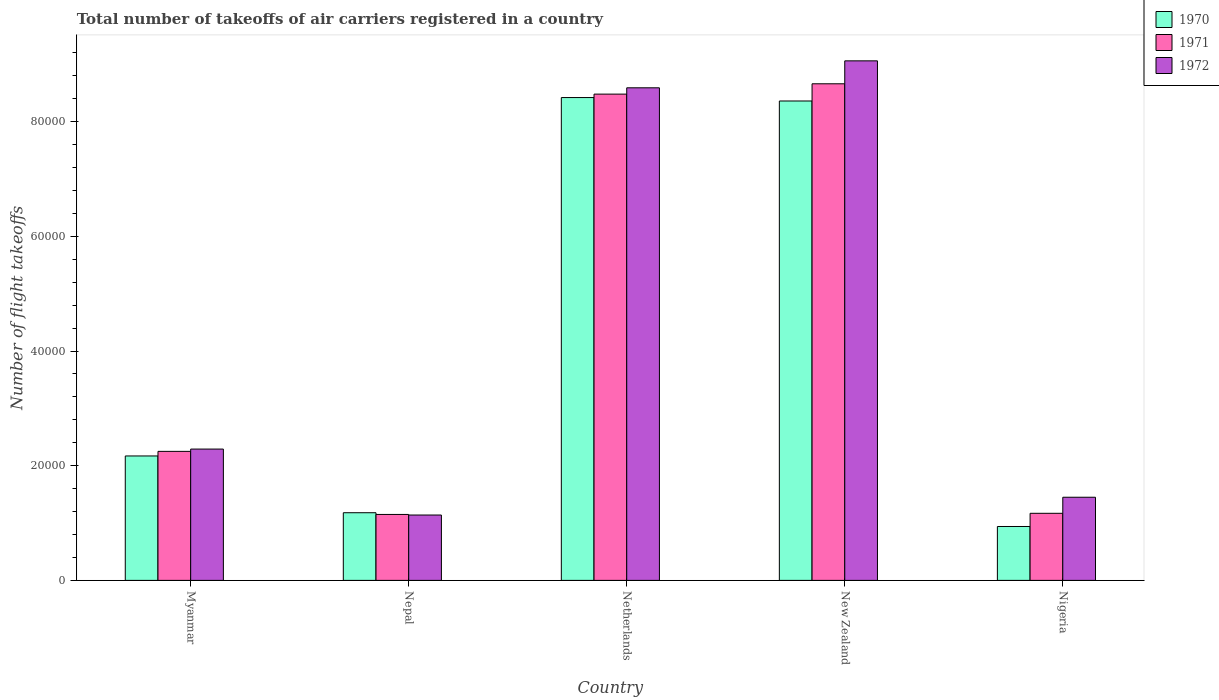How many different coloured bars are there?
Offer a very short reply. 3. How many groups of bars are there?
Offer a very short reply. 5. Are the number of bars per tick equal to the number of legend labels?
Offer a very short reply. Yes. How many bars are there on the 4th tick from the left?
Provide a short and direct response. 3. How many bars are there on the 4th tick from the right?
Make the answer very short. 3. What is the label of the 1st group of bars from the left?
Your answer should be compact. Myanmar. What is the total number of flight takeoffs in 1972 in Nepal?
Your answer should be very brief. 1.14e+04. Across all countries, what is the maximum total number of flight takeoffs in 1972?
Your answer should be very brief. 9.06e+04. Across all countries, what is the minimum total number of flight takeoffs in 1970?
Offer a very short reply. 9400. In which country was the total number of flight takeoffs in 1972 minimum?
Offer a very short reply. Nepal. What is the total total number of flight takeoffs in 1971 in the graph?
Make the answer very short. 2.17e+05. What is the difference between the total number of flight takeoffs in 1972 in Nepal and that in Nigeria?
Provide a succinct answer. -3100. What is the difference between the total number of flight takeoffs in 1972 in Netherlands and the total number of flight takeoffs in 1971 in Nigeria?
Offer a terse response. 7.42e+04. What is the average total number of flight takeoffs in 1971 per country?
Your response must be concise. 4.34e+04. What is the ratio of the total number of flight takeoffs in 1970 in Myanmar to that in Netherlands?
Offer a very short reply. 0.26. What is the difference between the highest and the second highest total number of flight takeoffs in 1971?
Make the answer very short. 1800. What is the difference between the highest and the lowest total number of flight takeoffs in 1972?
Give a very brief answer. 7.92e+04. Is the sum of the total number of flight takeoffs in 1971 in Nepal and Netherlands greater than the maximum total number of flight takeoffs in 1972 across all countries?
Provide a succinct answer. Yes. What does the 3rd bar from the left in Netherlands represents?
Provide a short and direct response. 1972. What does the 2nd bar from the right in Nigeria represents?
Provide a succinct answer. 1971. Is it the case that in every country, the sum of the total number of flight takeoffs in 1972 and total number of flight takeoffs in 1971 is greater than the total number of flight takeoffs in 1970?
Your response must be concise. Yes. Are all the bars in the graph horizontal?
Ensure brevity in your answer.  No. Does the graph contain any zero values?
Make the answer very short. No. Where does the legend appear in the graph?
Make the answer very short. Top right. How many legend labels are there?
Your answer should be very brief. 3. What is the title of the graph?
Offer a terse response. Total number of takeoffs of air carriers registered in a country. Does "1979" appear as one of the legend labels in the graph?
Your answer should be very brief. No. What is the label or title of the X-axis?
Provide a short and direct response. Country. What is the label or title of the Y-axis?
Your answer should be very brief. Number of flight takeoffs. What is the Number of flight takeoffs of 1970 in Myanmar?
Make the answer very short. 2.17e+04. What is the Number of flight takeoffs in 1971 in Myanmar?
Offer a terse response. 2.25e+04. What is the Number of flight takeoffs of 1972 in Myanmar?
Provide a short and direct response. 2.29e+04. What is the Number of flight takeoffs in 1970 in Nepal?
Your answer should be compact. 1.18e+04. What is the Number of flight takeoffs in 1971 in Nepal?
Provide a succinct answer. 1.15e+04. What is the Number of flight takeoffs of 1972 in Nepal?
Your answer should be very brief. 1.14e+04. What is the Number of flight takeoffs in 1970 in Netherlands?
Give a very brief answer. 8.42e+04. What is the Number of flight takeoffs of 1971 in Netherlands?
Ensure brevity in your answer.  8.48e+04. What is the Number of flight takeoffs in 1972 in Netherlands?
Provide a short and direct response. 8.59e+04. What is the Number of flight takeoffs of 1970 in New Zealand?
Provide a short and direct response. 8.36e+04. What is the Number of flight takeoffs in 1971 in New Zealand?
Provide a succinct answer. 8.66e+04. What is the Number of flight takeoffs of 1972 in New Zealand?
Provide a succinct answer. 9.06e+04. What is the Number of flight takeoffs in 1970 in Nigeria?
Ensure brevity in your answer.  9400. What is the Number of flight takeoffs in 1971 in Nigeria?
Give a very brief answer. 1.17e+04. What is the Number of flight takeoffs in 1972 in Nigeria?
Provide a succinct answer. 1.45e+04. Across all countries, what is the maximum Number of flight takeoffs in 1970?
Ensure brevity in your answer.  8.42e+04. Across all countries, what is the maximum Number of flight takeoffs in 1971?
Your response must be concise. 8.66e+04. Across all countries, what is the maximum Number of flight takeoffs of 1972?
Offer a terse response. 9.06e+04. Across all countries, what is the minimum Number of flight takeoffs in 1970?
Your response must be concise. 9400. Across all countries, what is the minimum Number of flight takeoffs in 1971?
Give a very brief answer. 1.15e+04. Across all countries, what is the minimum Number of flight takeoffs in 1972?
Your answer should be very brief. 1.14e+04. What is the total Number of flight takeoffs in 1970 in the graph?
Provide a short and direct response. 2.11e+05. What is the total Number of flight takeoffs in 1971 in the graph?
Provide a succinct answer. 2.17e+05. What is the total Number of flight takeoffs of 1972 in the graph?
Give a very brief answer. 2.25e+05. What is the difference between the Number of flight takeoffs of 1970 in Myanmar and that in Nepal?
Your answer should be very brief. 9900. What is the difference between the Number of flight takeoffs of 1971 in Myanmar and that in Nepal?
Your answer should be compact. 1.10e+04. What is the difference between the Number of flight takeoffs in 1972 in Myanmar and that in Nepal?
Offer a very short reply. 1.15e+04. What is the difference between the Number of flight takeoffs of 1970 in Myanmar and that in Netherlands?
Provide a short and direct response. -6.25e+04. What is the difference between the Number of flight takeoffs in 1971 in Myanmar and that in Netherlands?
Your answer should be very brief. -6.23e+04. What is the difference between the Number of flight takeoffs of 1972 in Myanmar and that in Netherlands?
Give a very brief answer. -6.30e+04. What is the difference between the Number of flight takeoffs in 1970 in Myanmar and that in New Zealand?
Keep it short and to the point. -6.19e+04. What is the difference between the Number of flight takeoffs in 1971 in Myanmar and that in New Zealand?
Provide a short and direct response. -6.41e+04. What is the difference between the Number of flight takeoffs in 1972 in Myanmar and that in New Zealand?
Your response must be concise. -6.77e+04. What is the difference between the Number of flight takeoffs in 1970 in Myanmar and that in Nigeria?
Keep it short and to the point. 1.23e+04. What is the difference between the Number of flight takeoffs in 1971 in Myanmar and that in Nigeria?
Give a very brief answer. 1.08e+04. What is the difference between the Number of flight takeoffs in 1972 in Myanmar and that in Nigeria?
Give a very brief answer. 8400. What is the difference between the Number of flight takeoffs of 1970 in Nepal and that in Netherlands?
Offer a terse response. -7.24e+04. What is the difference between the Number of flight takeoffs of 1971 in Nepal and that in Netherlands?
Keep it short and to the point. -7.33e+04. What is the difference between the Number of flight takeoffs of 1972 in Nepal and that in Netherlands?
Your response must be concise. -7.45e+04. What is the difference between the Number of flight takeoffs in 1970 in Nepal and that in New Zealand?
Offer a terse response. -7.18e+04. What is the difference between the Number of flight takeoffs of 1971 in Nepal and that in New Zealand?
Your answer should be very brief. -7.51e+04. What is the difference between the Number of flight takeoffs in 1972 in Nepal and that in New Zealand?
Make the answer very short. -7.92e+04. What is the difference between the Number of flight takeoffs in 1970 in Nepal and that in Nigeria?
Your answer should be very brief. 2400. What is the difference between the Number of flight takeoffs of 1971 in Nepal and that in Nigeria?
Give a very brief answer. -200. What is the difference between the Number of flight takeoffs of 1972 in Nepal and that in Nigeria?
Offer a very short reply. -3100. What is the difference between the Number of flight takeoffs of 1970 in Netherlands and that in New Zealand?
Ensure brevity in your answer.  600. What is the difference between the Number of flight takeoffs in 1971 in Netherlands and that in New Zealand?
Your answer should be very brief. -1800. What is the difference between the Number of flight takeoffs of 1972 in Netherlands and that in New Zealand?
Offer a very short reply. -4700. What is the difference between the Number of flight takeoffs of 1970 in Netherlands and that in Nigeria?
Make the answer very short. 7.48e+04. What is the difference between the Number of flight takeoffs of 1971 in Netherlands and that in Nigeria?
Provide a short and direct response. 7.31e+04. What is the difference between the Number of flight takeoffs in 1972 in Netherlands and that in Nigeria?
Your answer should be very brief. 7.14e+04. What is the difference between the Number of flight takeoffs in 1970 in New Zealand and that in Nigeria?
Give a very brief answer. 7.42e+04. What is the difference between the Number of flight takeoffs in 1971 in New Zealand and that in Nigeria?
Your answer should be compact. 7.49e+04. What is the difference between the Number of flight takeoffs of 1972 in New Zealand and that in Nigeria?
Give a very brief answer. 7.61e+04. What is the difference between the Number of flight takeoffs in 1970 in Myanmar and the Number of flight takeoffs in 1971 in Nepal?
Offer a terse response. 1.02e+04. What is the difference between the Number of flight takeoffs of 1970 in Myanmar and the Number of flight takeoffs of 1972 in Nepal?
Keep it short and to the point. 1.03e+04. What is the difference between the Number of flight takeoffs of 1971 in Myanmar and the Number of flight takeoffs of 1972 in Nepal?
Keep it short and to the point. 1.11e+04. What is the difference between the Number of flight takeoffs in 1970 in Myanmar and the Number of flight takeoffs in 1971 in Netherlands?
Provide a short and direct response. -6.31e+04. What is the difference between the Number of flight takeoffs of 1970 in Myanmar and the Number of flight takeoffs of 1972 in Netherlands?
Ensure brevity in your answer.  -6.42e+04. What is the difference between the Number of flight takeoffs in 1971 in Myanmar and the Number of flight takeoffs in 1972 in Netherlands?
Provide a succinct answer. -6.34e+04. What is the difference between the Number of flight takeoffs in 1970 in Myanmar and the Number of flight takeoffs in 1971 in New Zealand?
Offer a very short reply. -6.49e+04. What is the difference between the Number of flight takeoffs in 1970 in Myanmar and the Number of flight takeoffs in 1972 in New Zealand?
Your response must be concise. -6.89e+04. What is the difference between the Number of flight takeoffs in 1971 in Myanmar and the Number of flight takeoffs in 1972 in New Zealand?
Provide a short and direct response. -6.81e+04. What is the difference between the Number of flight takeoffs in 1970 in Myanmar and the Number of flight takeoffs in 1972 in Nigeria?
Make the answer very short. 7200. What is the difference between the Number of flight takeoffs in 1971 in Myanmar and the Number of flight takeoffs in 1972 in Nigeria?
Your response must be concise. 8000. What is the difference between the Number of flight takeoffs of 1970 in Nepal and the Number of flight takeoffs of 1971 in Netherlands?
Your answer should be very brief. -7.30e+04. What is the difference between the Number of flight takeoffs of 1970 in Nepal and the Number of flight takeoffs of 1972 in Netherlands?
Ensure brevity in your answer.  -7.41e+04. What is the difference between the Number of flight takeoffs of 1971 in Nepal and the Number of flight takeoffs of 1972 in Netherlands?
Give a very brief answer. -7.44e+04. What is the difference between the Number of flight takeoffs of 1970 in Nepal and the Number of flight takeoffs of 1971 in New Zealand?
Offer a very short reply. -7.48e+04. What is the difference between the Number of flight takeoffs in 1970 in Nepal and the Number of flight takeoffs in 1972 in New Zealand?
Offer a terse response. -7.88e+04. What is the difference between the Number of flight takeoffs of 1971 in Nepal and the Number of flight takeoffs of 1972 in New Zealand?
Keep it short and to the point. -7.91e+04. What is the difference between the Number of flight takeoffs of 1970 in Nepal and the Number of flight takeoffs of 1972 in Nigeria?
Make the answer very short. -2700. What is the difference between the Number of flight takeoffs of 1971 in Nepal and the Number of flight takeoffs of 1972 in Nigeria?
Offer a very short reply. -3000. What is the difference between the Number of flight takeoffs of 1970 in Netherlands and the Number of flight takeoffs of 1971 in New Zealand?
Your answer should be compact. -2400. What is the difference between the Number of flight takeoffs in 1970 in Netherlands and the Number of flight takeoffs in 1972 in New Zealand?
Make the answer very short. -6400. What is the difference between the Number of flight takeoffs of 1971 in Netherlands and the Number of flight takeoffs of 1972 in New Zealand?
Provide a short and direct response. -5800. What is the difference between the Number of flight takeoffs of 1970 in Netherlands and the Number of flight takeoffs of 1971 in Nigeria?
Offer a terse response. 7.25e+04. What is the difference between the Number of flight takeoffs of 1970 in Netherlands and the Number of flight takeoffs of 1972 in Nigeria?
Provide a short and direct response. 6.97e+04. What is the difference between the Number of flight takeoffs in 1971 in Netherlands and the Number of flight takeoffs in 1972 in Nigeria?
Ensure brevity in your answer.  7.03e+04. What is the difference between the Number of flight takeoffs of 1970 in New Zealand and the Number of flight takeoffs of 1971 in Nigeria?
Keep it short and to the point. 7.19e+04. What is the difference between the Number of flight takeoffs in 1970 in New Zealand and the Number of flight takeoffs in 1972 in Nigeria?
Give a very brief answer. 6.91e+04. What is the difference between the Number of flight takeoffs of 1971 in New Zealand and the Number of flight takeoffs of 1972 in Nigeria?
Make the answer very short. 7.21e+04. What is the average Number of flight takeoffs of 1970 per country?
Ensure brevity in your answer.  4.21e+04. What is the average Number of flight takeoffs in 1971 per country?
Ensure brevity in your answer.  4.34e+04. What is the average Number of flight takeoffs of 1972 per country?
Your answer should be very brief. 4.51e+04. What is the difference between the Number of flight takeoffs of 1970 and Number of flight takeoffs of 1971 in Myanmar?
Ensure brevity in your answer.  -800. What is the difference between the Number of flight takeoffs in 1970 and Number of flight takeoffs in 1972 in Myanmar?
Offer a very short reply. -1200. What is the difference between the Number of flight takeoffs in 1971 and Number of flight takeoffs in 1972 in Myanmar?
Offer a very short reply. -400. What is the difference between the Number of flight takeoffs of 1970 and Number of flight takeoffs of 1971 in Nepal?
Offer a terse response. 300. What is the difference between the Number of flight takeoffs of 1970 and Number of flight takeoffs of 1971 in Netherlands?
Your answer should be very brief. -600. What is the difference between the Number of flight takeoffs of 1970 and Number of flight takeoffs of 1972 in Netherlands?
Your answer should be compact. -1700. What is the difference between the Number of flight takeoffs in 1971 and Number of flight takeoffs in 1972 in Netherlands?
Provide a short and direct response. -1100. What is the difference between the Number of flight takeoffs in 1970 and Number of flight takeoffs in 1971 in New Zealand?
Offer a very short reply. -3000. What is the difference between the Number of flight takeoffs in 1970 and Number of flight takeoffs in 1972 in New Zealand?
Provide a short and direct response. -7000. What is the difference between the Number of flight takeoffs of 1971 and Number of flight takeoffs of 1972 in New Zealand?
Your answer should be very brief. -4000. What is the difference between the Number of flight takeoffs of 1970 and Number of flight takeoffs of 1971 in Nigeria?
Offer a very short reply. -2300. What is the difference between the Number of flight takeoffs in 1970 and Number of flight takeoffs in 1972 in Nigeria?
Provide a succinct answer. -5100. What is the difference between the Number of flight takeoffs in 1971 and Number of flight takeoffs in 1972 in Nigeria?
Give a very brief answer. -2800. What is the ratio of the Number of flight takeoffs of 1970 in Myanmar to that in Nepal?
Give a very brief answer. 1.84. What is the ratio of the Number of flight takeoffs in 1971 in Myanmar to that in Nepal?
Make the answer very short. 1.96. What is the ratio of the Number of flight takeoffs of 1972 in Myanmar to that in Nepal?
Your response must be concise. 2.01. What is the ratio of the Number of flight takeoffs of 1970 in Myanmar to that in Netherlands?
Ensure brevity in your answer.  0.26. What is the ratio of the Number of flight takeoffs in 1971 in Myanmar to that in Netherlands?
Provide a short and direct response. 0.27. What is the ratio of the Number of flight takeoffs in 1972 in Myanmar to that in Netherlands?
Your response must be concise. 0.27. What is the ratio of the Number of flight takeoffs in 1970 in Myanmar to that in New Zealand?
Your answer should be compact. 0.26. What is the ratio of the Number of flight takeoffs of 1971 in Myanmar to that in New Zealand?
Your answer should be very brief. 0.26. What is the ratio of the Number of flight takeoffs of 1972 in Myanmar to that in New Zealand?
Provide a short and direct response. 0.25. What is the ratio of the Number of flight takeoffs of 1970 in Myanmar to that in Nigeria?
Your answer should be compact. 2.31. What is the ratio of the Number of flight takeoffs of 1971 in Myanmar to that in Nigeria?
Provide a succinct answer. 1.92. What is the ratio of the Number of flight takeoffs of 1972 in Myanmar to that in Nigeria?
Make the answer very short. 1.58. What is the ratio of the Number of flight takeoffs in 1970 in Nepal to that in Netherlands?
Make the answer very short. 0.14. What is the ratio of the Number of flight takeoffs in 1971 in Nepal to that in Netherlands?
Your answer should be compact. 0.14. What is the ratio of the Number of flight takeoffs in 1972 in Nepal to that in Netherlands?
Give a very brief answer. 0.13. What is the ratio of the Number of flight takeoffs in 1970 in Nepal to that in New Zealand?
Your response must be concise. 0.14. What is the ratio of the Number of flight takeoffs of 1971 in Nepal to that in New Zealand?
Keep it short and to the point. 0.13. What is the ratio of the Number of flight takeoffs of 1972 in Nepal to that in New Zealand?
Your answer should be very brief. 0.13. What is the ratio of the Number of flight takeoffs of 1970 in Nepal to that in Nigeria?
Provide a short and direct response. 1.26. What is the ratio of the Number of flight takeoffs in 1971 in Nepal to that in Nigeria?
Offer a terse response. 0.98. What is the ratio of the Number of flight takeoffs of 1972 in Nepal to that in Nigeria?
Your response must be concise. 0.79. What is the ratio of the Number of flight takeoffs in 1971 in Netherlands to that in New Zealand?
Your response must be concise. 0.98. What is the ratio of the Number of flight takeoffs in 1972 in Netherlands to that in New Zealand?
Your answer should be compact. 0.95. What is the ratio of the Number of flight takeoffs of 1970 in Netherlands to that in Nigeria?
Offer a very short reply. 8.96. What is the ratio of the Number of flight takeoffs in 1971 in Netherlands to that in Nigeria?
Your response must be concise. 7.25. What is the ratio of the Number of flight takeoffs of 1972 in Netherlands to that in Nigeria?
Provide a short and direct response. 5.92. What is the ratio of the Number of flight takeoffs in 1970 in New Zealand to that in Nigeria?
Your response must be concise. 8.89. What is the ratio of the Number of flight takeoffs in 1971 in New Zealand to that in Nigeria?
Keep it short and to the point. 7.4. What is the ratio of the Number of flight takeoffs of 1972 in New Zealand to that in Nigeria?
Provide a succinct answer. 6.25. What is the difference between the highest and the second highest Number of flight takeoffs of 1970?
Keep it short and to the point. 600. What is the difference between the highest and the second highest Number of flight takeoffs of 1971?
Your answer should be very brief. 1800. What is the difference between the highest and the second highest Number of flight takeoffs in 1972?
Make the answer very short. 4700. What is the difference between the highest and the lowest Number of flight takeoffs in 1970?
Make the answer very short. 7.48e+04. What is the difference between the highest and the lowest Number of flight takeoffs in 1971?
Your answer should be very brief. 7.51e+04. What is the difference between the highest and the lowest Number of flight takeoffs of 1972?
Provide a short and direct response. 7.92e+04. 